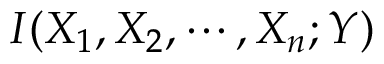<formula> <loc_0><loc_0><loc_500><loc_500>I ( X _ { 1 } , X _ { 2 } , \cdots , X _ { n } ; Y )</formula> 